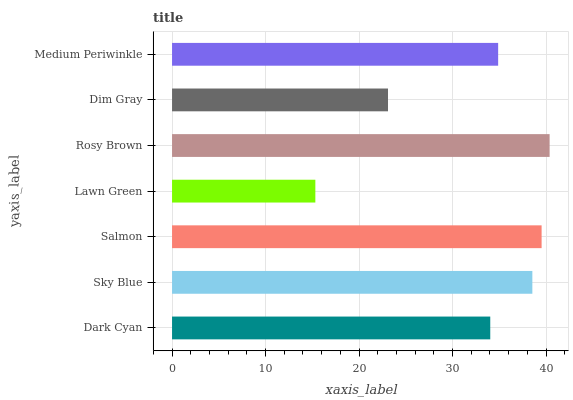Is Lawn Green the minimum?
Answer yes or no. Yes. Is Rosy Brown the maximum?
Answer yes or no. Yes. Is Sky Blue the minimum?
Answer yes or no. No. Is Sky Blue the maximum?
Answer yes or no. No. Is Sky Blue greater than Dark Cyan?
Answer yes or no. Yes. Is Dark Cyan less than Sky Blue?
Answer yes or no. Yes. Is Dark Cyan greater than Sky Blue?
Answer yes or no. No. Is Sky Blue less than Dark Cyan?
Answer yes or no. No. Is Medium Periwinkle the high median?
Answer yes or no. Yes. Is Medium Periwinkle the low median?
Answer yes or no. Yes. Is Sky Blue the high median?
Answer yes or no. No. Is Dark Cyan the low median?
Answer yes or no. No. 